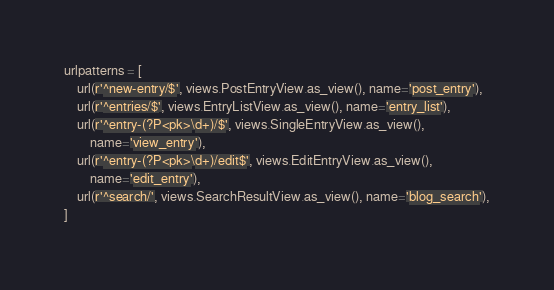Convert code to text. <code><loc_0><loc_0><loc_500><loc_500><_Python_>
urlpatterns = [
    url(r'^new-entry/$', views.PostEntryView.as_view(), name='post_entry'),
    url(r'^entries/$', views.EntryListView.as_view(), name='entry_list'),
    url(r'^entry-(?P<pk>\d+)/$', views.SingleEntryView.as_view(),
        name='view_entry'),
    url(r'^entry-(?P<pk>\d+)/edit$', views.EditEntryView.as_view(),
        name='edit_entry'),
    url(r'^search/', views.SearchResultView.as_view(), name='blog_search'),
]
</code> 